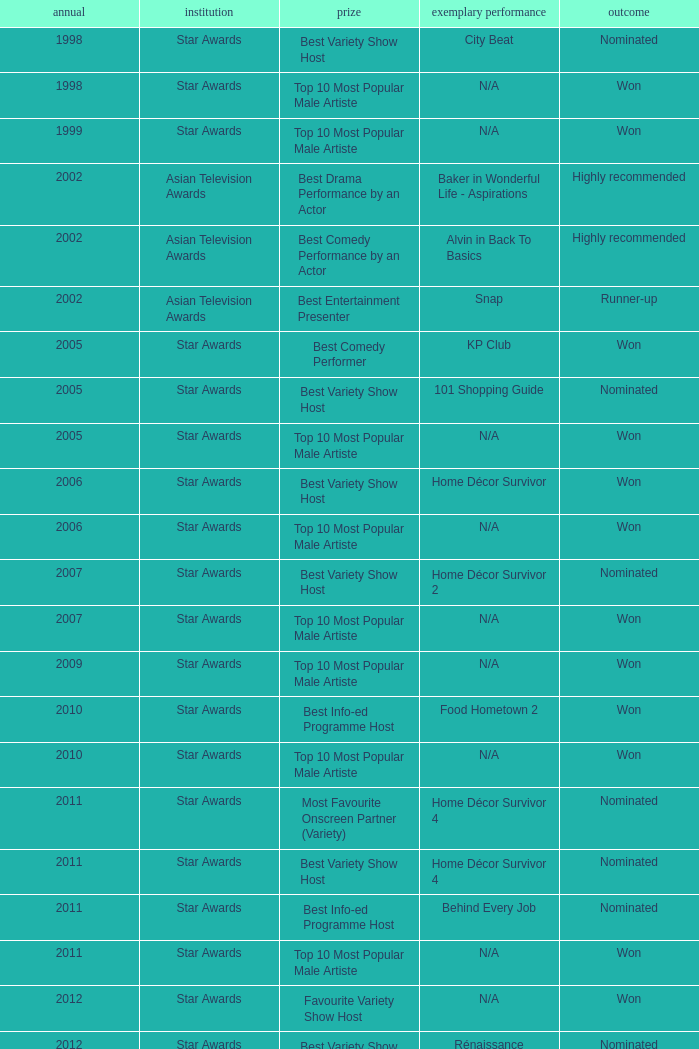What is the name of the Representative Work in a year later than 2005 with a Result of nominated, and an Award of best variety show host? Home Décor Survivor 2, Home Décor Survivor 4, Rénaissance, Jobs Around The World. 